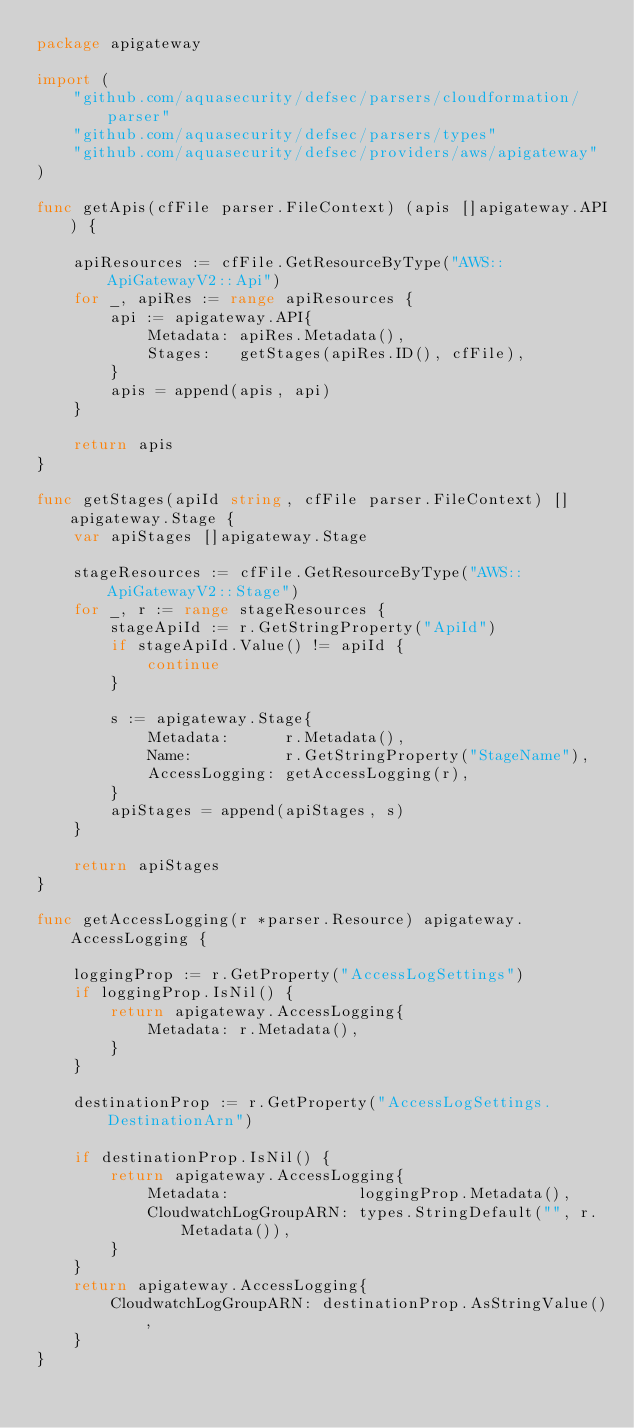Convert code to text. <code><loc_0><loc_0><loc_500><loc_500><_Go_>package apigateway

import (
	"github.com/aquasecurity/defsec/parsers/cloudformation/parser"
	"github.com/aquasecurity/defsec/parsers/types"
	"github.com/aquasecurity/defsec/providers/aws/apigateway"
)

func getApis(cfFile parser.FileContext) (apis []apigateway.API) {

	apiResources := cfFile.GetResourceByType("AWS::ApiGatewayV2::Api")
	for _, apiRes := range apiResources {
		api := apigateway.API{
			Metadata: apiRes.Metadata(),
			Stages:   getStages(apiRes.ID(), cfFile),
		}
		apis = append(apis, api)
	}

	return apis
}

func getStages(apiId string, cfFile parser.FileContext) []apigateway.Stage {
	var apiStages []apigateway.Stage

	stageResources := cfFile.GetResourceByType("AWS::ApiGatewayV2::Stage")
	for _, r := range stageResources {
		stageApiId := r.GetStringProperty("ApiId")
		if stageApiId.Value() != apiId {
			continue
		}

		s := apigateway.Stage{
			Metadata:      r.Metadata(),
			Name:          r.GetStringProperty("StageName"),
			AccessLogging: getAccessLogging(r),
		}
		apiStages = append(apiStages, s)
	}

	return apiStages
}

func getAccessLogging(r *parser.Resource) apigateway.AccessLogging {

	loggingProp := r.GetProperty("AccessLogSettings")
	if loggingProp.IsNil() {
		return apigateway.AccessLogging{
			Metadata: r.Metadata(),
		}
	}

	destinationProp := r.GetProperty("AccessLogSettings.DestinationArn")

	if destinationProp.IsNil() {
		return apigateway.AccessLogging{
			Metadata:              loggingProp.Metadata(),
			CloudwatchLogGroupARN: types.StringDefault("", r.Metadata()),
		}
	}
	return apigateway.AccessLogging{
		CloudwatchLogGroupARN: destinationProp.AsStringValue(),
	}
}
</code> 